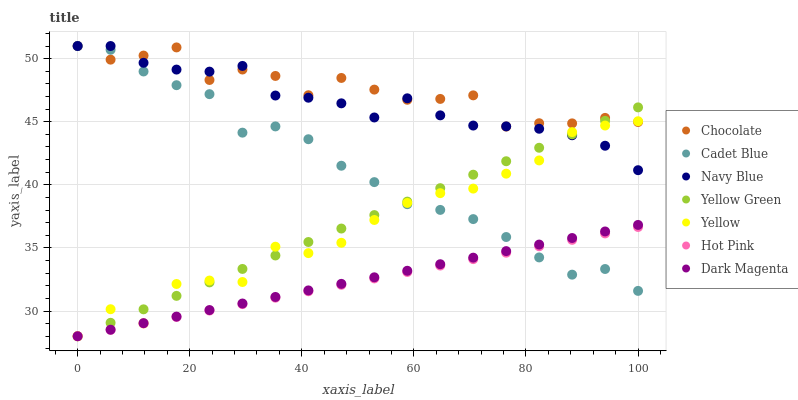Does Hot Pink have the minimum area under the curve?
Answer yes or no. Yes. Does Chocolate have the maximum area under the curve?
Answer yes or no. Yes. Does Yellow Green have the minimum area under the curve?
Answer yes or no. No. Does Yellow Green have the maximum area under the curve?
Answer yes or no. No. Is Hot Pink the smoothest?
Answer yes or no. Yes. Is Yellow the roughest?
Answer yes or no. Yes. Is Yellow Green the smoothest?
Answer yes or no. No. Is Yellow Green the roughest?
Answer yes or no. No. Does Yellow Green have the lowest value?
Answer yes or no. Yes. Does Navy Blue have the lowest value?
Answer yes or no. No. Does Chocolate have the highest value?
Answer yes or no. Yes. Does Yellow Green have the highest value?
Answer yes or no. No. Is Dark Magenta less than Chocolate?
Answer yes or no. Yes. Is Navy Blue greater than Dark Magenta?
Answer yes or no. Yes. Does Hot Pink intersect Yellow Green?
Answer yes or no. Yes. Is Hot Pink less than Yellow Green?
Answer yes or no. No. Is Hot Pink greater than Yellow Green?
Answer yes or no. No. Does Dark Magenta intersect Chocolate?
Answer yes or no. No. 